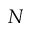Convert formula to latex. <formula><loc_0><loc_0><loc_500><loc_500>N</formula> 